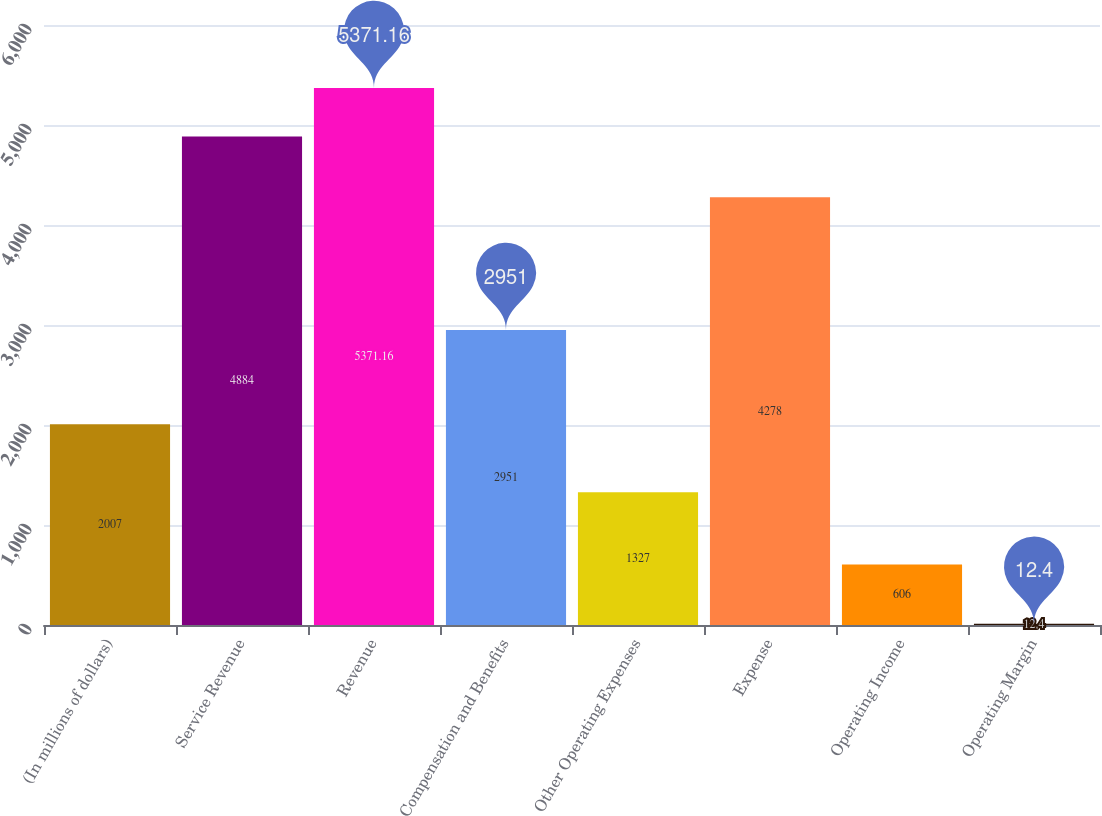<chart> <loc_0><loc_0><loc_500><loc_500><bar_chart><fcel>(In millions of dollars)<fcel>Service Revenue<fcel>Revenue<fcel>Compensation and Benefits<fcel>Other Operating Expenses<fcel>Expense<fcel>Operating Income<fcel>Operating Margin<nl><fcel>2007<fcel>4884<fcel>5371.16<fcel>2951<fcel>1327<fcel>4278<fcel>606<fcel>12.4<nl></chart> 